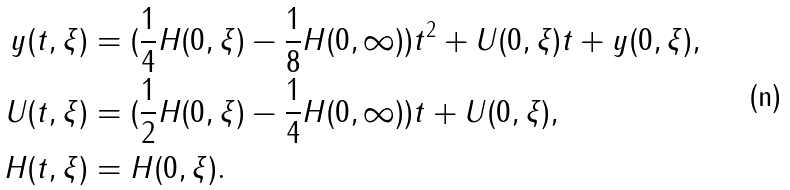Convert formula to latex. <formula><loc_0><loc_0><loc_500><loc_500>y ( t , \xi ) & = ( \frac { 1 } { 4 } H ( 0 , \xi ) - \frac { 1 } { 8 } H ( 0 , \infty ) ) t ^ { 2 } + U ( 0 , \xi ) t + y ( 0 , \xi ) , \\ U ( t , \xi ) & = ( \frac { 1 } { 2 } H ( 0 , \xi ) - \frac { 1 } { 4 } H ( 0 , \infty ) ) t + U ( 0 , \xi ) , \\ H ( t , \xi ) & = H ( 0 , \xi ) .</formula> 